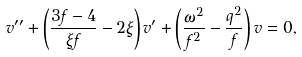<formula> <loc_0><loc_0><loc_500><loc_500>v ^ { \prime \prime } + \left ( \frac { 3 f - 4 } { \xi f } - 2 \xi \right ) v ^ { \prime } + \left ( \frac { \omega ^ { 2 } } { f ^ { 2 } } - \frac { q ^ { 2 } } { f } \right ) v = 0 ,</formula> 